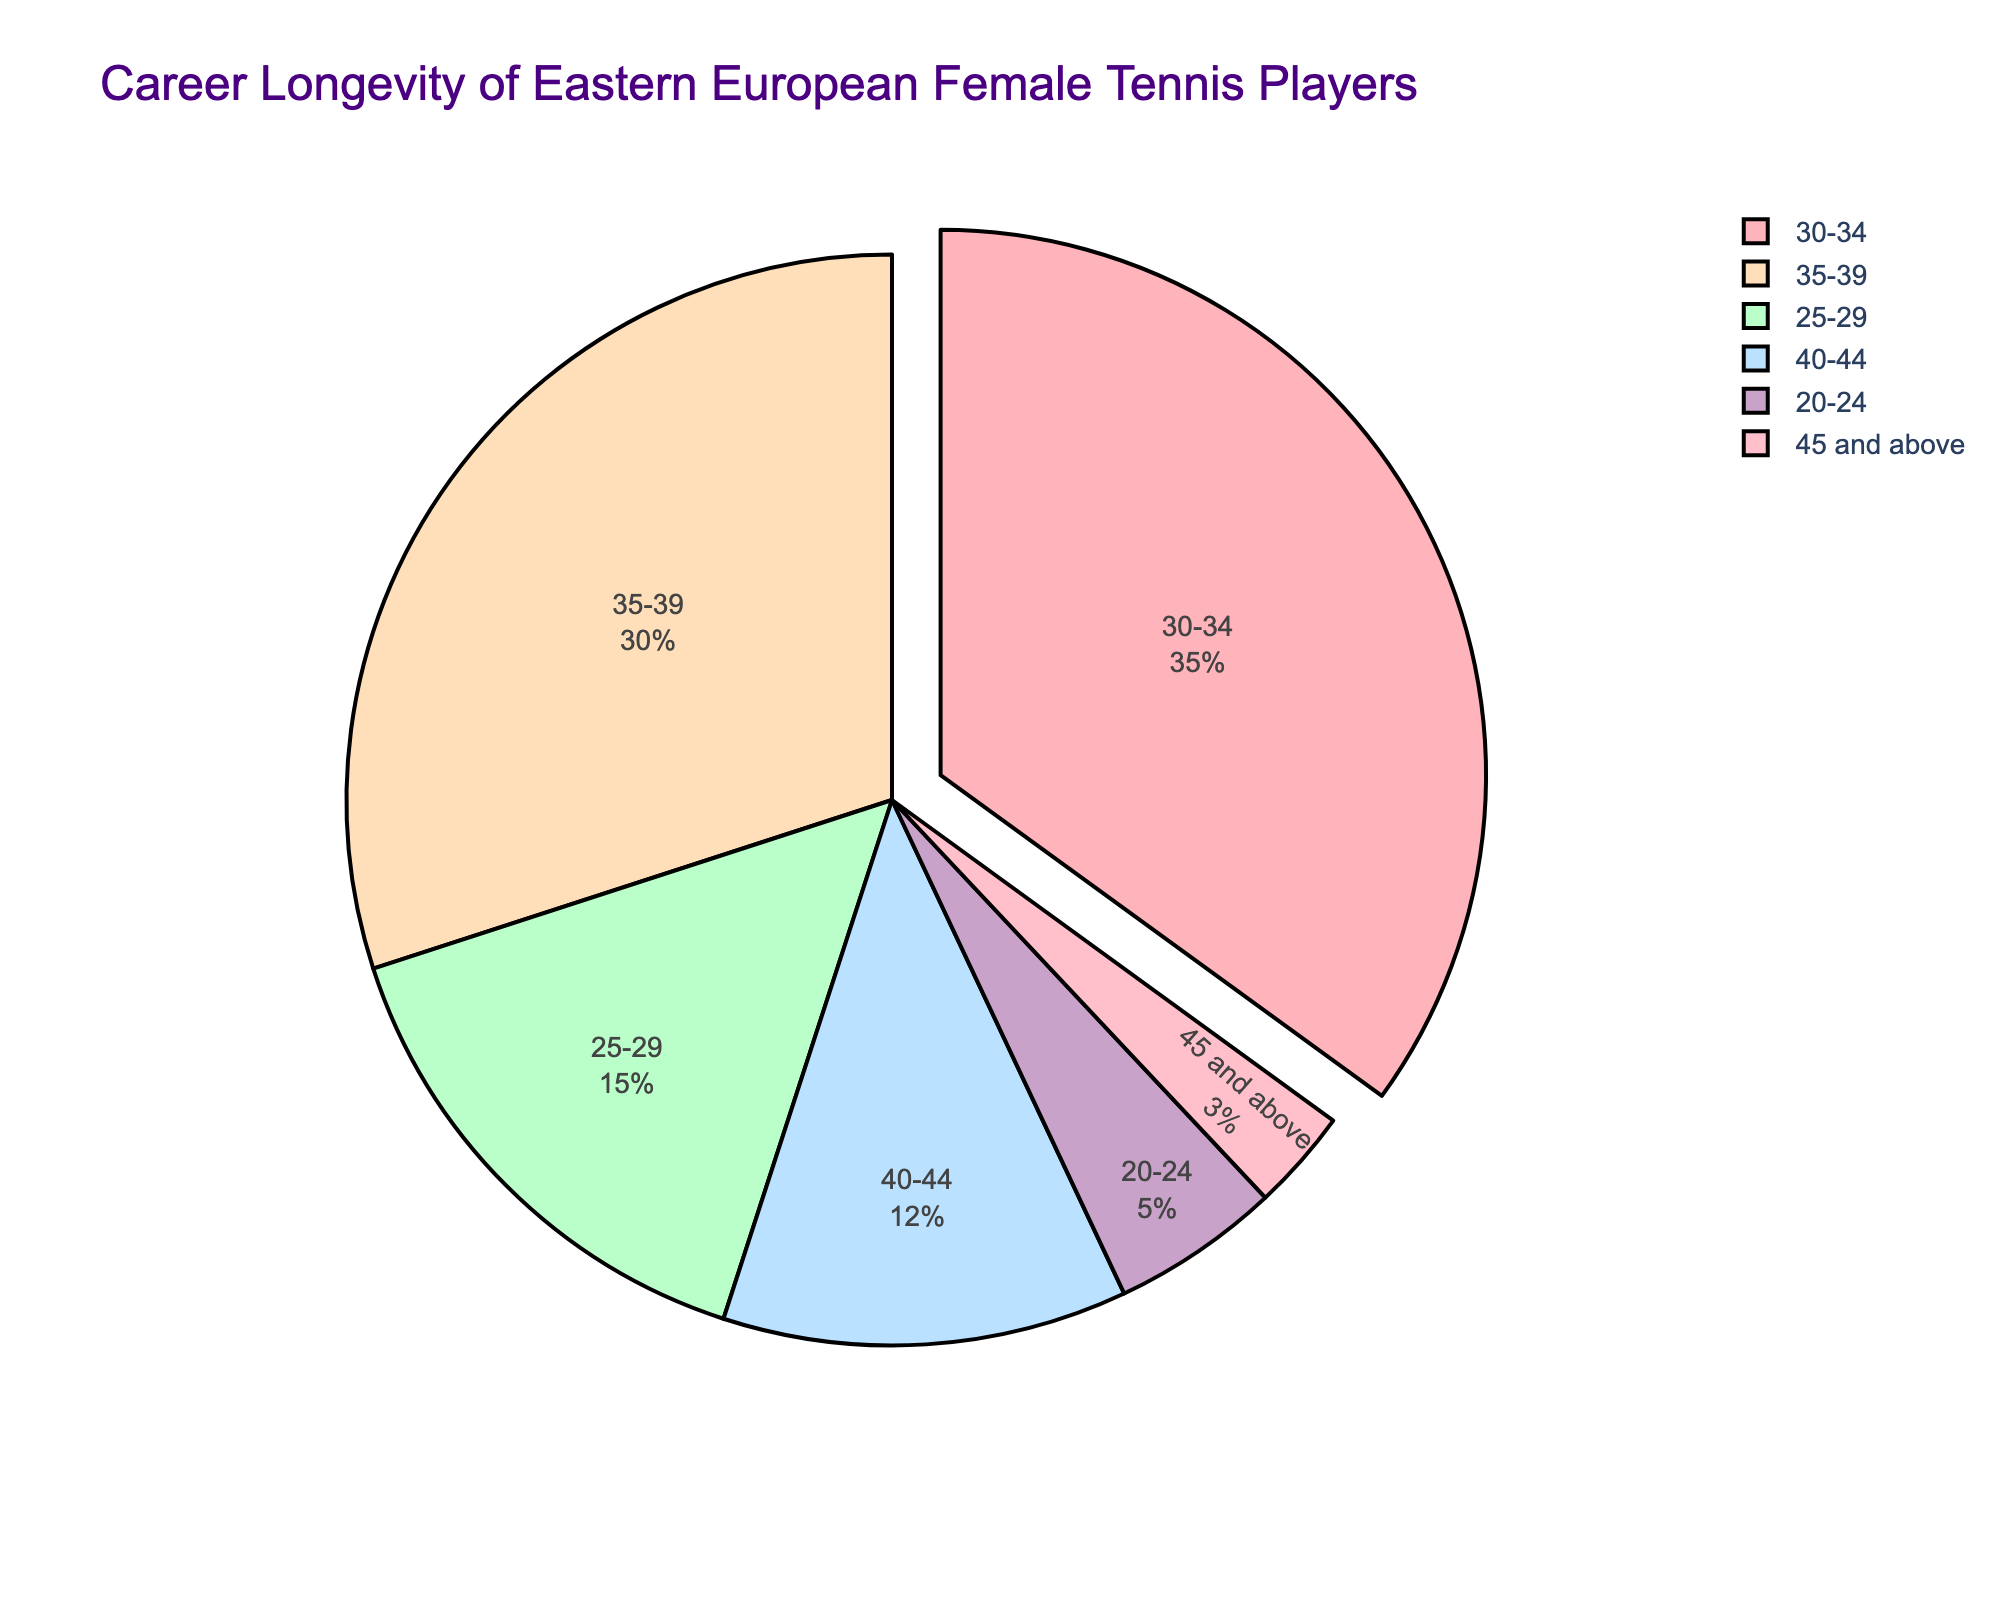What's the percentage of players who retired at age 30-34? The section labeled "30-34" shows the percentage of players who retired in this age range.
Answer: 35% Which age range has the highest percentage of retirements? The largest segment and the segment that is pulled out from the pie chart indicates the age range with the highest percentage of retirements.
Answer: 30-34 What is the combined percentage of players who retired at age 25-29 and 35-39? Add the percentages for the age ranges "25-29" and "35-39": 15% + 30%.
Answer: 45% How does the percentage of retirements at age 20-24 compare to those at age 45 and above? Compare the "20-24" segment (5%) to the "45 and above" segment (3%).
Answer: Greater for 20-24 What is the percentage difference between the youngest retiree group (20-24) and the oldest retiree group (45 and above)? Subtract the percentage for "45 and above" (3%) from "20-24" (5%).
Answer: 2% What is the total percentage of players who retired at age 40 and above? Add the percentages for the ranges "40-44" (12%) and "45 and above" (3%).
Answer: 15% What percentage of players retire before age 30? Add the percentages for "20-24" (5%) and "25-29" (15%).
Answer: 20% Which color represents the age range 35-39 in the pie chart? Look for the color of the pie segment labeled "35-39".
Answer: Light blue How many age ranges have a retirement percentage below 10%? Count the segments with percentages below 10%. "20-24" (5%) and "45 and above" (3%).
Answer: 2 If we consider players retiring below age 35 as early retirees, what percentage of players retire early? Sum the percentages of "20-24" (5%), "25-29" (15%), and "30-34" (35%).
Answer: 55% 